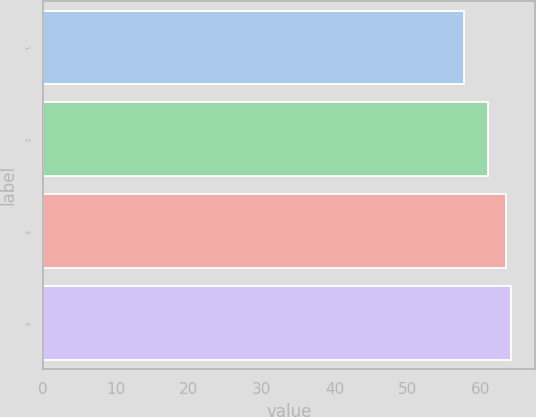<chart> <loc_0><loc_0><loc_500><loc_500><bar_chart><fcel>1<fcel>2<fcel>3<fcel>4<nl><fcel>57.79<fcel>61.01<fcel>63.42<fcel>64.23<nl></chart> 